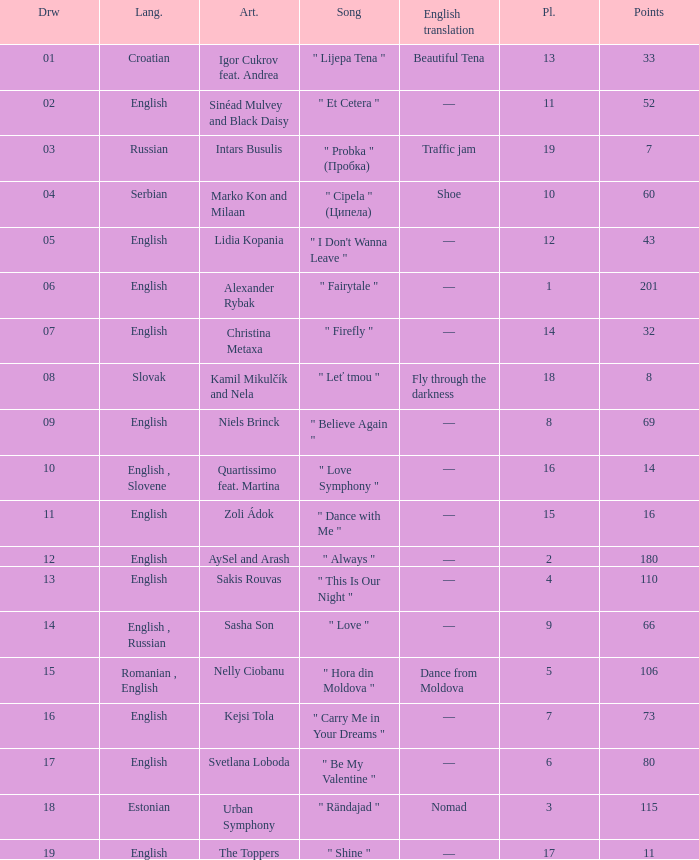What is the place when the draw is less than 12 and the artist is quartissimo feat. martina? 16.0. 